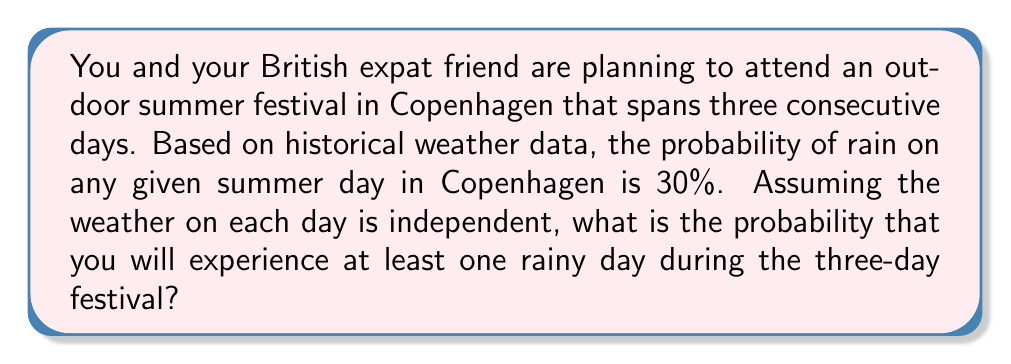Help me with this question. Let's approach this step-by-step:

1) First, let's define our events:
   Let R be the event of experiencing at least one rainy day during the festival.
   Let N be the event of experiencing no rainy days during the festival.

2) We're looking for P(R), but it's easier to calculate P(N) and then use the complement rule.

3) For N to occur, it must not rain on any of the three days. The probability of no rain on a single day is:

   $P(\text{no rain on one day}) = 1 - P(\text{rain on one day}) = 1 - 0.30 = 0.70$

4) Since the weather on each day is independent, we can use the multiplication rule. The probability of no rain for all three days is:

   $P(N) = 0.70 \times 0.70 \times 0.70 = 0.70^3 = 0.343$

5) Now we can use the complement rule to find P(R):

   $P(R) = 1 - P(N) = 1 - 0.343 = 0.657$

6) Convert to a percentage:

   $0.657 \times 100\% = 65.7\%$

Therefore, the probability of experiencing at least one rainy day during the three-day festival is approximately 65.7%.
Answer: The probability of experiencing at least one rainy day during the three-day outdoor summer festival in Copenhagen is approximately $65.7\%$. 